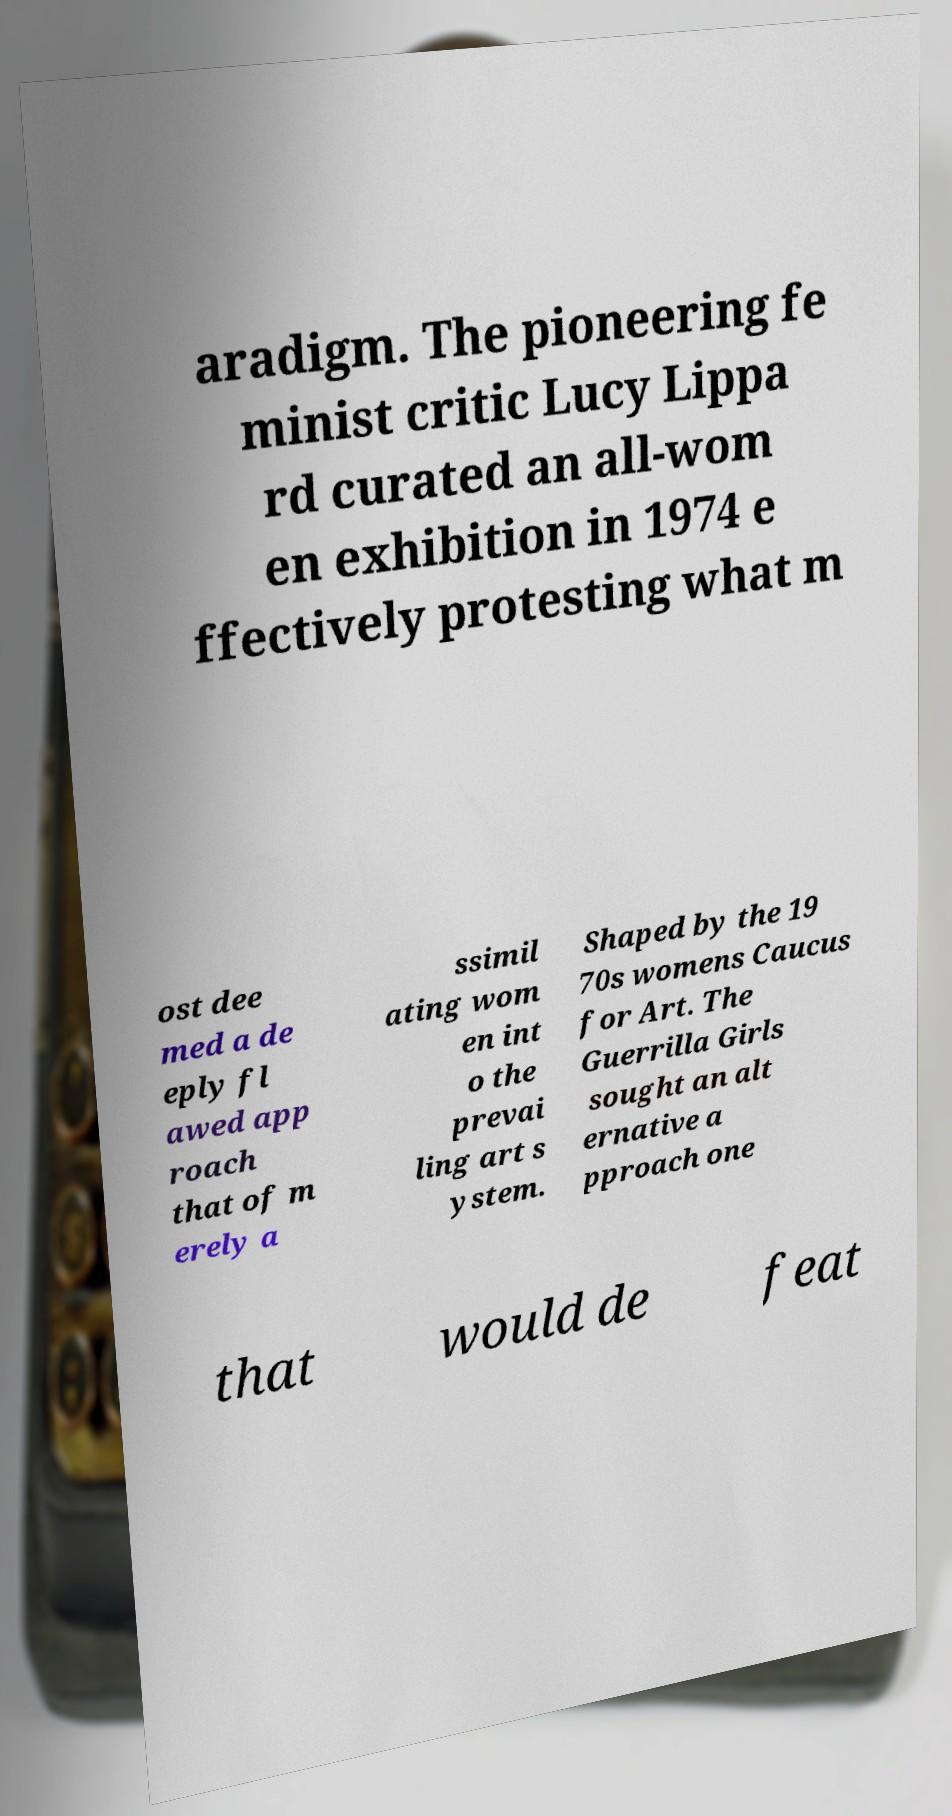I need the written content from this picture converted into text. Can you do that? aradigm. The pioneering fe minist critic Lucy Lippa rd curated an all-wom en exhibition in 1974 e ffectively protesting what m ost dee med a de eply fl awed app roach that of m erely a ssimil ating wom en int o the prevai ling art s ystem. Shaped by the 19 70s womens Caucus for Art. The Guerrilla Girls sought an alt ernative a pproach one that would de feat 